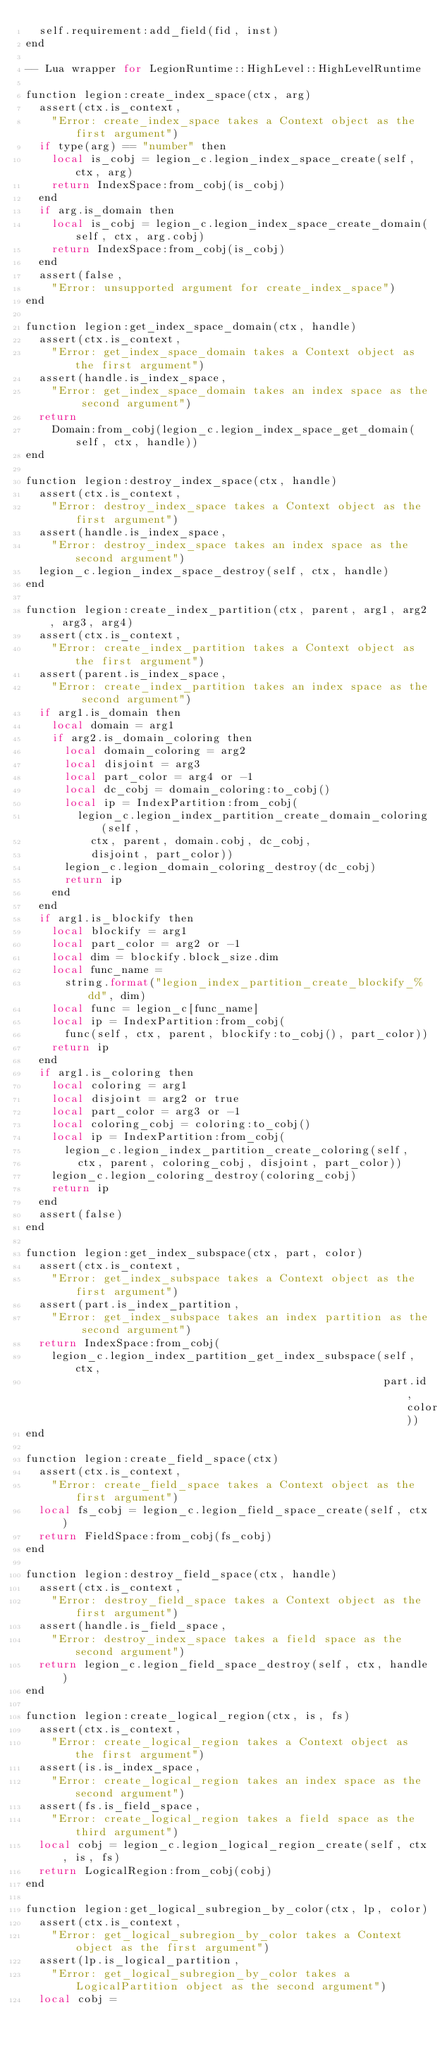<code> <loc_0><loc_0><loc_500><loc_500><_Perl_>  self.requirement:add_field(fid, inst)
end

-- Lua wrapper for LegionRuntime::HighLevel::HighLevelRuntime

function legion:create_index_space(ctx, arg)
  assert(ctx.is_context,
    "Error: create_index_space takes a Context object as the first argument")
  if type(arg) == "number" then
    local is_cobj = legion_c.legion_index_space_create(self, ctx, arg)
    return IndexSpace:from_cobj(is_cobj)
  end
  if arg.is_domain then
    local is_cobj = legion_c.legion_index_space_create_domain(self, ctx, arg.cobj)
    return IndexSpace:from_cobj(is_cobj)
  end
  assert(false,
    "Error: unsupported argument for create_index_space")
end

function legion:get_index_space_domain(ctx, handle)
  assert(ctx.is_context,
    "Error: get_index_space_domain takes a Context object as the first argument")
  assert(handle.is_index_space,
    "Error: get_index_space_domain takes an index space as the second argument")
  return
    Domain:from_cobj(legion_c.legion_index_space_get_domain(self, ctx, handle))
end

function legion:destroy_index_space(ctx, handle)
  assert(ctx.is_context,
    "Error: destroy_index_space takes a Context object as the first argument")
  assert(handle.is_index_space,
    "Error: destroy_index_space takes an index space as the second argument")
  legion_c.legion_index_space_destroy(self, ctx, handle)
end

function legion:create_index_partition(ctx, parent, arg1, arg2, arg3, arg4)
  assert(ctx.is_context,
    "Error: create_index_partition takes a Context object as the first argument")
  assert(parent.is_index_space,
    "Error: create_index_partition takes an index space as the second argument")
  if arg1.is_domain then
    local domain = arg1
    if arg2.is_domain_coloring then
      local domain_coloring = arg2
      local disjoint = arg3
      local part_color = arg4 or -1
      local dc_cobj = domain_coloring:to_cobj()
      local ip = IndexPartition:from_cobj(
        legion_c.legion_index_partition_create_domain_coloring(self,
          ctx, parent, domain.cobj, dc_cobj,
          disjoint, part_color))
      legion_c.legion_domain_coloring_destroy(dc_cobj)
      return ip
    end
  end
  if arg1.is_blockify then
    local blockify = arg1
    local part_color = arg2 or -1
    local dim = blockify.block_size.dim
    local func_name =
      string.format("legion_index_partition_create_blockify_%dd", dim)
    local func = legion_c[func_name]
    local ip = IndexPartition:from_cobj(
      func(self, ctx, parent, blockify:to_cobj(), part_color))
    return ip
  end
  if arg1.is_coloring then
    local coloring = arg1
    local disjoint = arg2 or true
    local part_color = arg3 or -1
    local coloring_cobj = coloring:to_cobj()
    local ip = IndexPartition:from_cobj(
      legion_c.legion_index_partition_create_coloring(self,
        ctx, parent, coloring_cobj, disjoint, part_color))
    legion_c.legion_coloring_destroy(coloring_cobj)
    return ip
  end
  assert(false)
end

function legion:get_index_subspace(ctx, part, color)
  assert(ctx.is_context,
    "Error: get_index_subspace takes a Context object as the first argument")
  assert(part.is_index_partition,
    "Error: get_index_subspace takes an index partition as the second argument")
  return IndexSpace:from_cobj(
    legion_c.legion_index_partition_get_index_subspace(self, ctx,
                                                       part.id, color))
end

function legion:create_field_space(ctx)
  assert(ctx.is_context,
    "Error: create_field_space takes a Context object as the first argument")
  local fs_cobj = legion_c.legion_field_space_create(self, ctx)
  return FieldSpace:from_cobj(fs_cobj)
end

function legion:destroy_field_space(ctx, handle)
  assert(ctx.is_context,
    "Error: destroy_field_space takes a Context object as the first argument")
  assert(handle.is_field_space,
    "Error: destroy_index_space takes a field space as the second argument")
  return legion_c.legion_field_space_destroy(self, ctx, handle)
end

function legion:create_logical_region(ctx, is, fs)
  assert(ctx.is_context,
    "Error: create_logical_region takes a Context object as the first argument")
  assert(is.is_index_space,
    "Error: create_logical_region takes an index space as the second argument")
  assert(fs.is_field_space,
    "Error: create_logical_region takes a field space as the third argument")
  local cobj = legion_c.legion_logical_region_create(self, ctx, is, fs)
  return LogicalRegion:from_cobj(cobj)
end

function legion:get_logical_subregion_by_color(ctx, lp, color)
  assert(ctx.is_context,
    "Error: get_logical_subregion_by_color takes a Context object as the first argument")
  assert(lp.is_logical_partition,
    "Error: get_logical_subregion_by_color takes a LogicalPartition object as the second argument")
  local cobj =</code> 